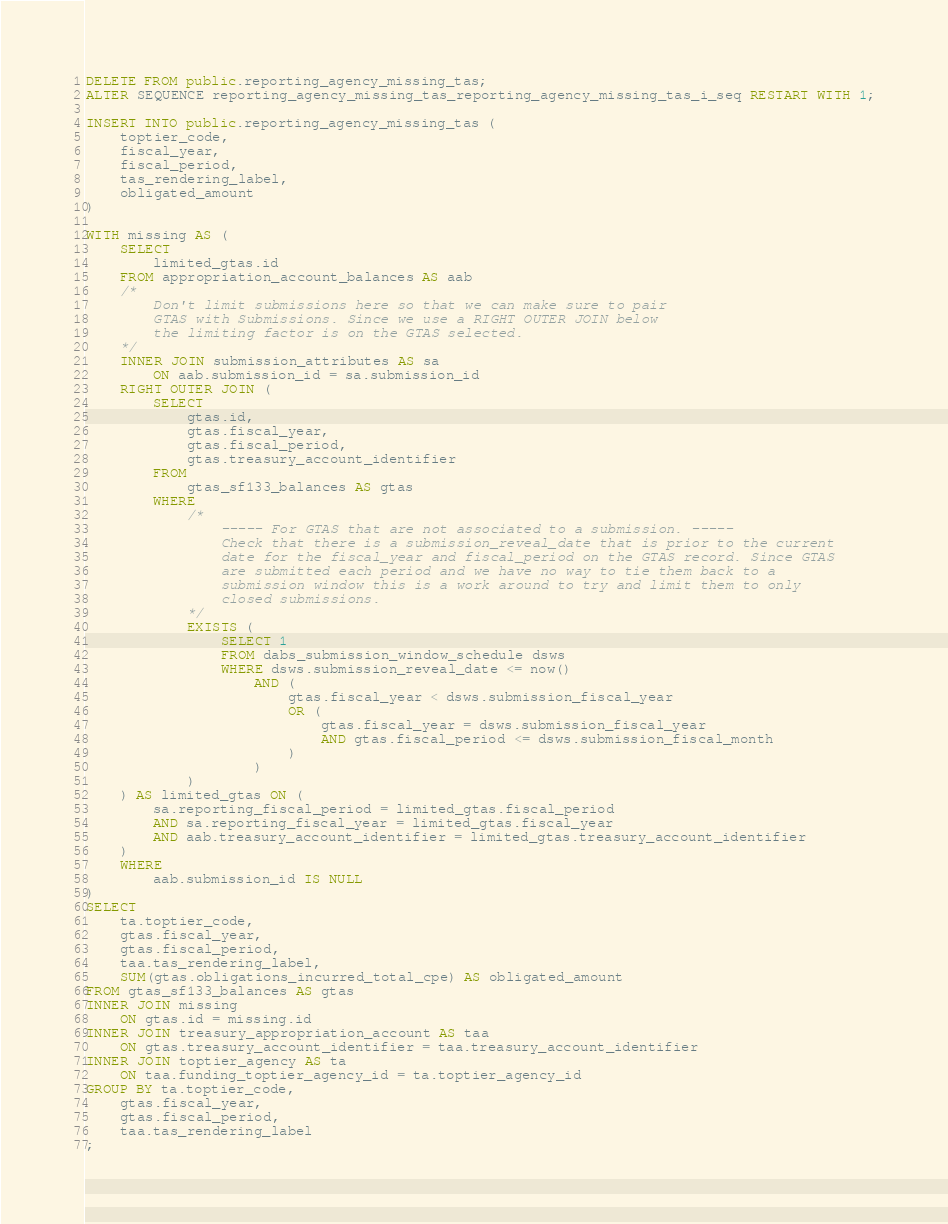Convert code to text. <code><loc_0><loc_0><loc_500><loc_500><_SQL_>DELETE FROM public.reporting_agency_missing_tas;
ALTER SEQUENCE reporting_agency_missing_tas_reporting_agency_missing_tas_i_seq RESTART WITH 1;

INSERT INTO public.reporting_agency_missing_tas (
    toptier_code,
    fiscal_year,
    fiscal_period,
    tas_rendering_label,
    obligated_amount
)

WITH missing AS (
    SELECT
        limited_gtas.id
    FROM appropriation_account_balances AS aab
    /*
        Don't limit submissions here so that we can make sure to pair
        GTAS with Submissions. Since we use a RIGHT OUTER JOIN below
        the limiting factor is on the GTAS selected.
    */
    INNER JOIN submission_attributes AS sa
        ON aab.submission_id = sa.submission_id
    RIGHT OUTER JOIN (
        SELECT
            gtas.id,
            gtas.fiscal_year,
            gtas.fiscal_period,
            gtas.treasury_account_identifier
        FROM
            gtas_sf133_balances AS gtas
        WHERE
            /*
                ----- For GTAS that are not associated to a submission. -----
                Check that there is a submission_reveal_date that is prior to the current
                date for the fiscal_year and fiscal_period on the GTAS record. Since GTAS
                are submitted each period and we have no way to tie them back to a
                submission window this is a work around to try and limit them to only
                closed submissions.
            */
            EXISTS (
                SELECT 1
                FROM dabs_submission_window_schedule dsws
                WHERE dsws.submission_reveal_date <= now()
                    AND (
                        gtas.fiscal_year < dsws.submission_fiscal_year
                        OR (
                            gtas.fiscal_year = dsws.submission_fiscal_year
                            AND gtas.fiscal_period <= dsws.submission_fiscal_month
                        )
                    )
            )
    ) AS limited_gtas ON (
        sa.reporting_fiscal_period = limited_gtas.fiscal_period
        AND sa.reporting_fiscal_year = limited_gtas.fiscal_year
        AND aab.treasury_account_identifier = limited_gtas.treasury_account_identifier
    )
    WHERE
        aab.submission_id IS NULL
)
SELECT
    ta.toptier_code,
    gtas.fiscal_year,
    gtas.fiscal_period,
    taa.tas_rendering_label,
    SUM(gtas.obligations_incurred_total_cpe) AS obligated_amount
FROM gtas_sf133_balances AS gtas
INNER JOIN missing
    ON gtas.id = missing.id
INNER JOIN treasury_appropriation_account AS taa
    ON gtas.treasury_account_identifier = taa.treasury_account_identifier
INNER JOIN toptier_agency AS ta
    ON taa.funding_toptier_agency_id = ta.toptier_agency_id
GROUP BY ta.toptier_code,
    gtas.fiscal_year,
    gtas.fiscal_period,
    taa.tas_rendering_label
;
</code> 